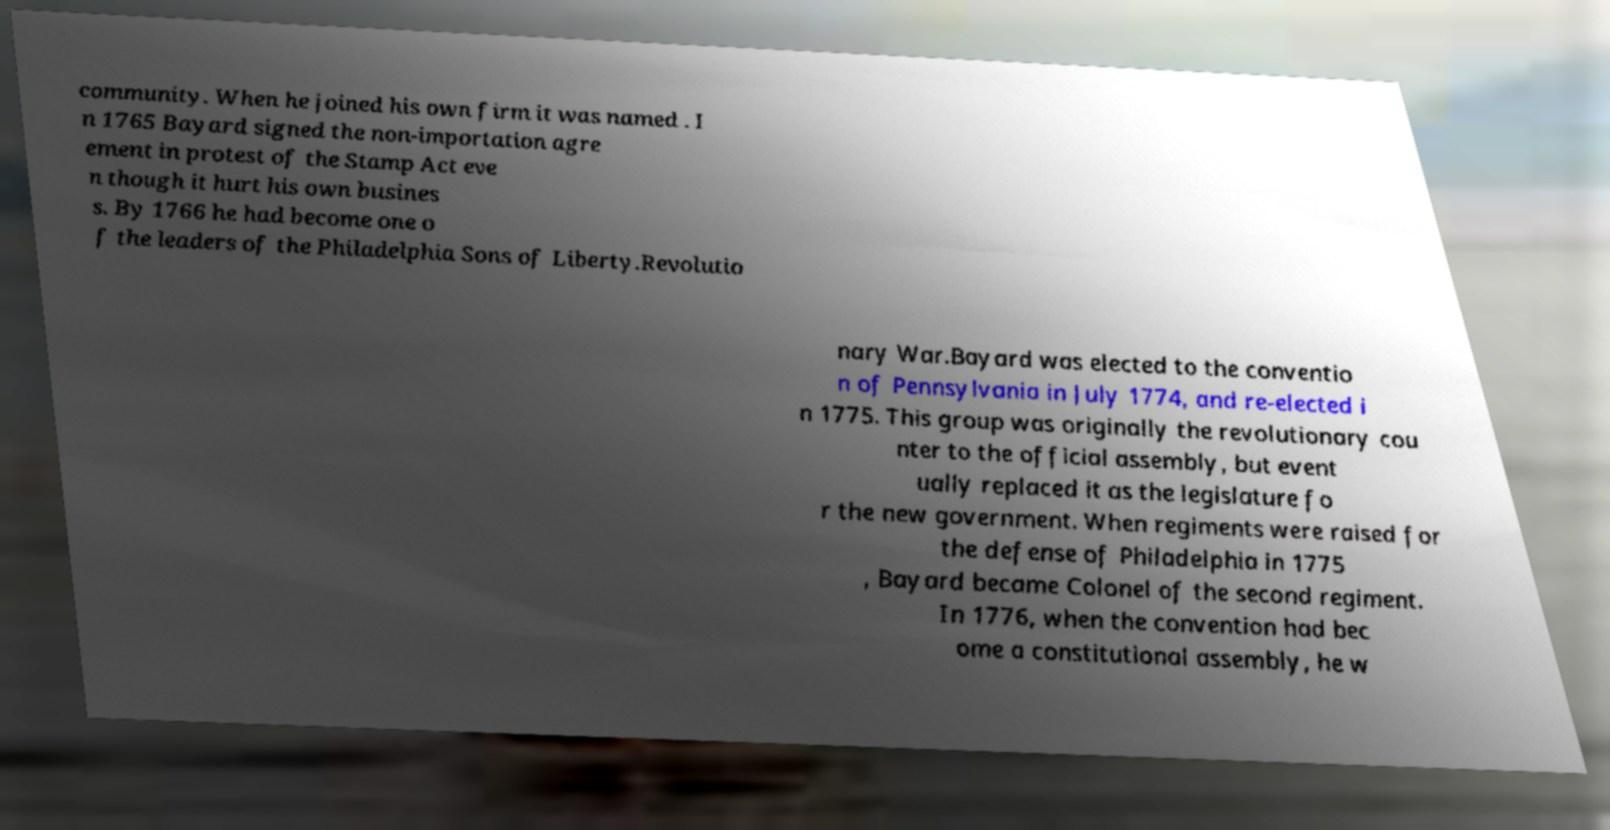There's text embedded in this image that I need extracted. Can you transcribe it verbatim? community. When he joined his own firm it was named . I n 1765 Bayard signed the non-importation agre ement in protest of the Stamp Act eve n though it hurt his own busines s. By 1766 he had become one o f the leaders of the Philadelphia Sons of Liberty.Revolutio nary War.Bayard was elected to the conventio n of Pennsylvania in July 1774, and re-elected i n 1775. This group was originally the revolutionary cou nter to the official assembly, but event ually replaced it as the legislature fo r the new government. When regiments were raised for the defense of Philadelphia in 1775 , Bayard became Colonel of the second regiment. In 1776, when the convention had bec ome a constitutional assembly, he w 